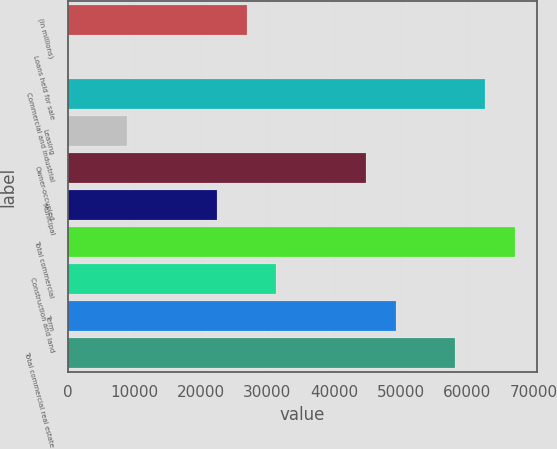<chart> <loc_0><loc_0><loc_500><loc_500><bar_chart><fcel>(In millions)<fcel>Loans held for sale<fcel>Commercial and industrial<fcel>Leasing<fcel>Owner-occupied<fcel>Municipal<fcel>Total commercial<fcel>Construction and land<fcel>Term<fcel>Total commercial real estate<nl><fcel>26885.6<fcel>44<fcel>62674.4<fcel>8991.2<fcel>44780<fcel>22412<fcel>67148<fcel>31359.2<fcel>49253.6<fcel>58200.8<nl></chart> 